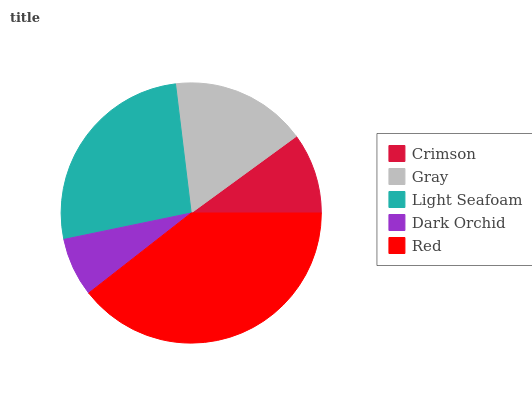Is Dark Orchid the minimum?
Answer yes or no. Yes. Is Red the maximum?
Answer yes or no. Yes. Is Gray the minimum?
Answer yes or no. No. Is Gray the maximum?
Answer yes or no. No. Is Gray greater than Crimson?
Answer yes or no. Yes. Is Crimson less than Gray?
Answer yes or no. Yes. Is Crimson greater than Gray?
Answer yes or no. No. Is Gray less than Crimson?
Answer yes or no. No. Is Gray the high median?
Answer yes or no. Yes. Is Gray the low median?
Answer yes or no. Yes. Is Red the high median?
Answer yes or no. No. Is Crimson the low median?
Answer yes or no. No. 